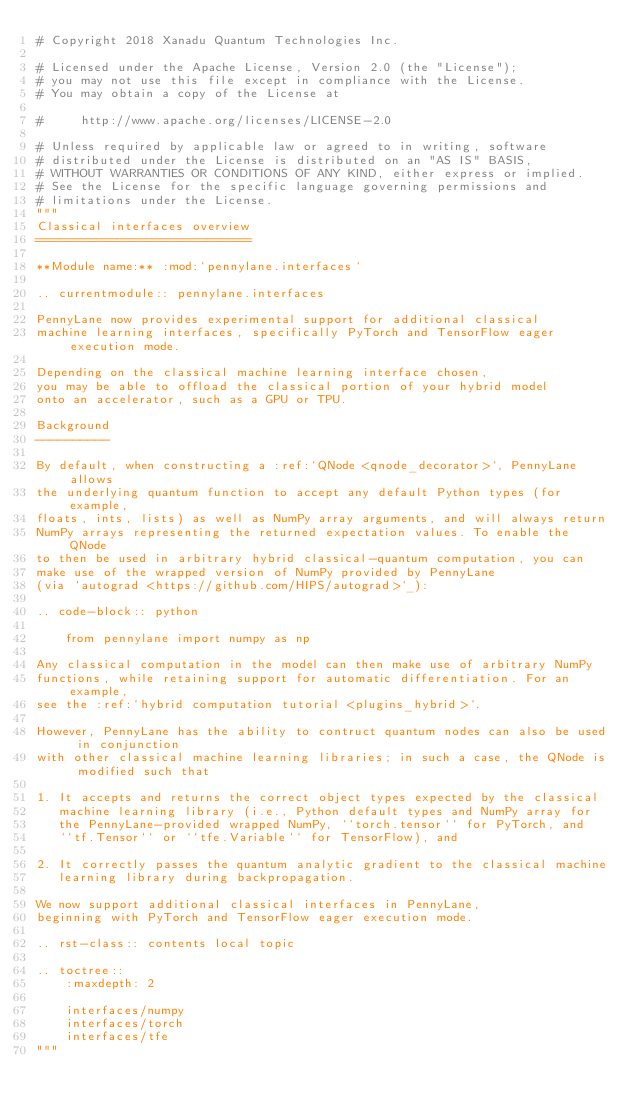Convert code to text. <code><loc_0><loc_0><loc_500><loc_500><_Python_># Copyright 2018 Xanadu Quantum Technologies Inc.

# Licensed under the Apache License, Version 2.0 (the "License");
# you may not use this file except in compliance with the License.
# You may obtain a copy of the License at

#     http://www.apache.org/licenses/LICENSE-2.0

# Unless required by applicable law or agreed to in writing, software
# distributed under the License is distributed on an "AS IS" BASIS,
# WITHOUT WARRANTIES OR CONDITIONS OF ANY KIND, either express or implied.
# See the License for the specific language governing permissions and
# limitations under the License.
"""
Classical interfaces overview
=============================

**Module name:** :mod:`pennylane.interfaces`

.. currentmodule:: pennylane.interfaces

PennyLane now provides experimental support for additional classical
machine learning interfaces, specifically PyTorch and TensorFlow eager execution mode.

Depending on the classical machine learning interface chosen,
you may be able to offload the classical portion of your hybrid model
onto an accelerator, such as a GPU or TPU.

Background
----------

By default, when constructing a :ref:`QNode <qnode_decorator>`, PennyLane allows
the underlying quantum function to accept any default Python types (for example,
floats, ints, lists) as well as NumPy array arguments, and will always return
NumPy arrays representing the returned expectation values. To enable the QNode
to then be used in arbitrary hybrid classical-quantum computation, you can
make use of the wrapped version of NumPy provided by PennyLane
(via `autograd <https://github.com/HIPS/autograd>`_):

.. code-block:: python

    from pennylane import numpy as np

Any classical computation in the model can then make use of arbitrary NumPy
functions, while retaining support for automatic differentiation. For an example,
see the :ref:`hybrid computation tutorial <plugins_hybrid>`.

However, PennyLane has the ability to contruct quantum nodes can also be used in conjunction
with other classical machine learning libraries; in such a case, the QNode is modified such that

1. It accepts and returns the correct object types expected by the classical
   machine learning library (i.e., Python default types and NumPy array for
   the PennyLane-provided wrapped NumPy, ``torch.tensor`` for PyTorch, and
   ``tf.Tensor`` or ``tfe.Variable`` for TensorFlow), and

2. It correctly passes the quantum analytic gradient to the classical machine
   learning library during backpropagation.

We now support additional classical interfaces in PennyLane,
beginning with PyTorch and TensorFlow eager execution mode.

.. rst-class:: contents local topic

.. toctree::
    :maxdepth: 2

    interfaces/numpy
    interfaces/torch
    interfaces/tfe
"""
</code> 